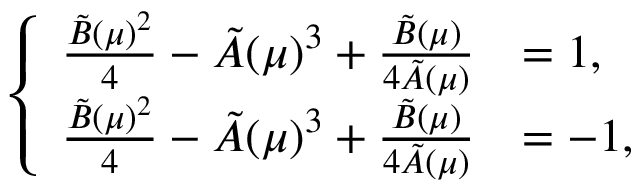Convert formula to latex. <formula><loc_0><loc_0><loc_500><loc_500>\left \{ \begin{array} { l l } { \frac { \tilde { B } ( \mu ) ^ { 2 } } { 4 } - \tilde { A } ( \mu ) ^ { 3 } + \frac { \tilde { B } ( \mu ) } { 4 \tilde { A } ( \mu ) } } & { = 1 , } \\ { \frac { \tilde { B } ( \mu ) ^ { 2 } } { 4 } - \tilde { A } ( \mu ) ^ { 3 } + \frac { \tilde { B } ( \mu ) } { 4 \tilde { A } ( \mu ) } } & { = - 1 , } \end{array}</formula> 